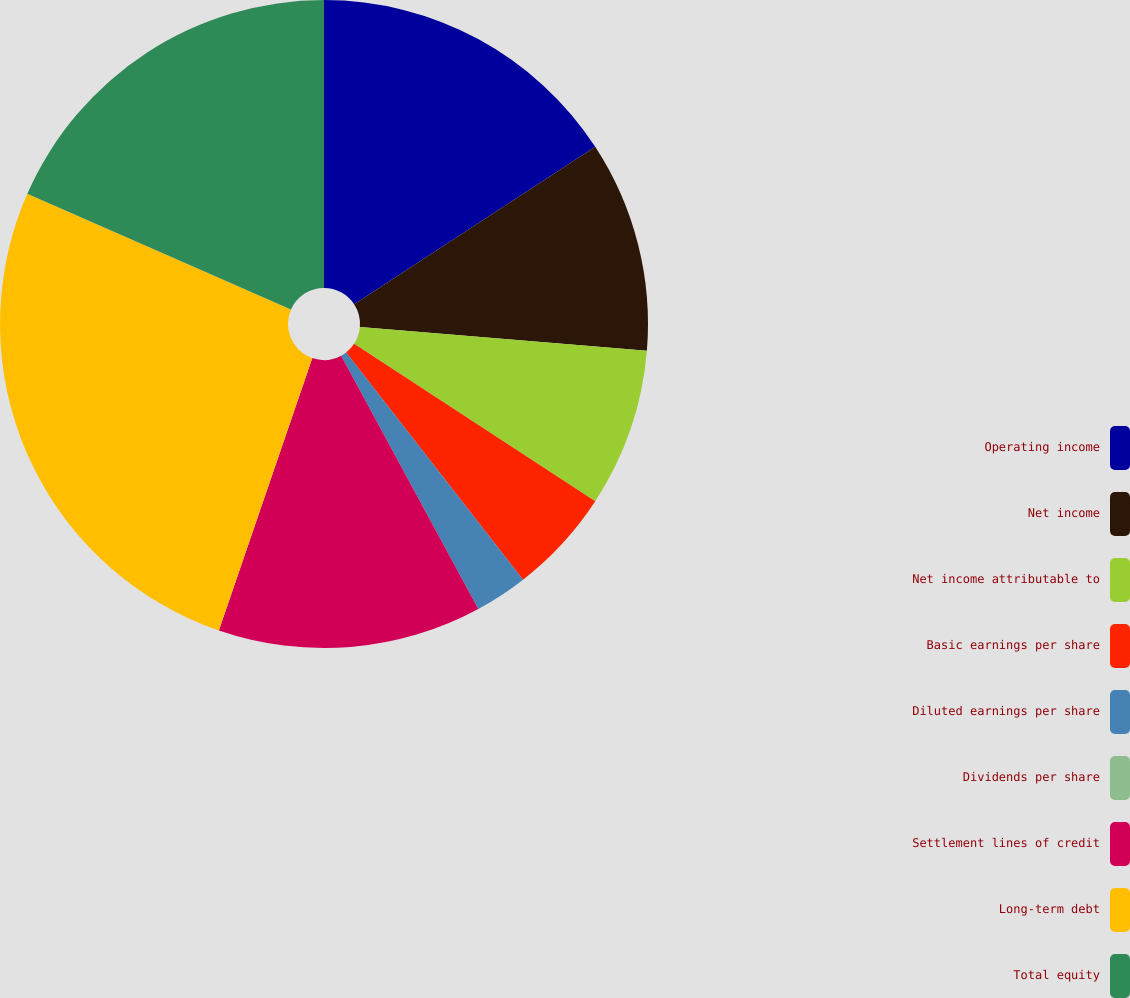<chart> <loc_0><loc_0><loc_500><loc_500><pie_chart><fcel>Operating income<fcel>Net income<fcel>Net income attributable to<fcel>Basic earnings per share<fcel>Diluted earnings per share<fcel>Dividends per share<fcel>Settlement lines of credit<fcel>Long-term debt<fcel>Total equity<nl><fcel>15.79%<fcel>10.53%<fcel>7.89%<fcel>5.26%<fcel>2.63%<fcel>0.0%<fcel>13.16%<fcel>26.32%<fcel>18.42%<nl></chart> 